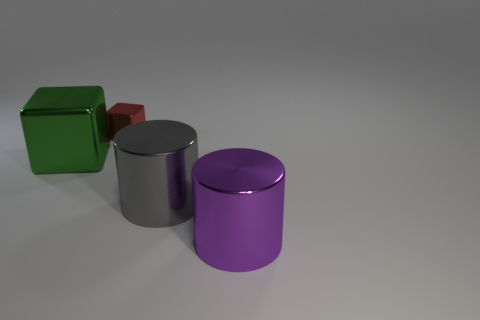Does the small metal block have the same color as the big metallic block?
Offer a terse response. No. Is there any other thing that has the same shape as the gray metallic thing?
Your response must be concise. Yes. There is a big thing behind the large gray thing right of the large green metal block; what shape is it?
Provide a succinct answer. Cube. There is a gray object that is the same material as the purple thing; what shape is it?
Offer a very short reply. Cylinder. There is a cylinder behind the large thing that is to the right of the gray cylinder; what size is it?
Keep it short and to the point. Large. What is the shape of the big purple object?
Offer a very short reply. Cylinder. How many big objects are either gray cylinders or cyan metal cylinders?
Provide a succinct answer. 1. The purple thing that is the same shape as the large gray object is what size?
Provide a succinct answer. Large. How many things are both behind the gray object and right of the big green shiny cube?
Make the answer very short. 1. Do the gray metallic thing and the object in front of the gray metallic object have the same shape?
Provide a short and direct response. Yes. 